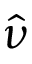Convert formula to latex. <formula><loc_0><loc_0><loc_500><loc_500>\hat { \nu }</formula> 